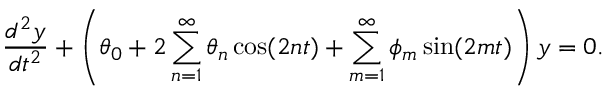Convert formula to latex. <formula><loc_0><loc_0><loc_500><loc_500>{ \frac { d ^ { 2 } y } { d t ^ { 2 } } } + \left ( \theta _ { 0 } + 2 \sum _ { n = 1 } ^ { \infty } \theta _ { n } \cos ( 2 n t ) + \sum _ { m = 1 } ^ { \infty } \phi _ { m } \sin ( 2 m t ) \right ) y = 0 .</formula> 